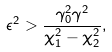Convert formula to latex. <formula><loc_0><loc_0><loc_500><loc_500>\epsilon ^ { 2 } > \frac { \gamma _ { 0 } ^ { 2 } \gamma ^ { 2 } } { \chi _ { 1 } ^ { 2 } - \chi _ { 2 } ^ { 2 } } ,</formula> 